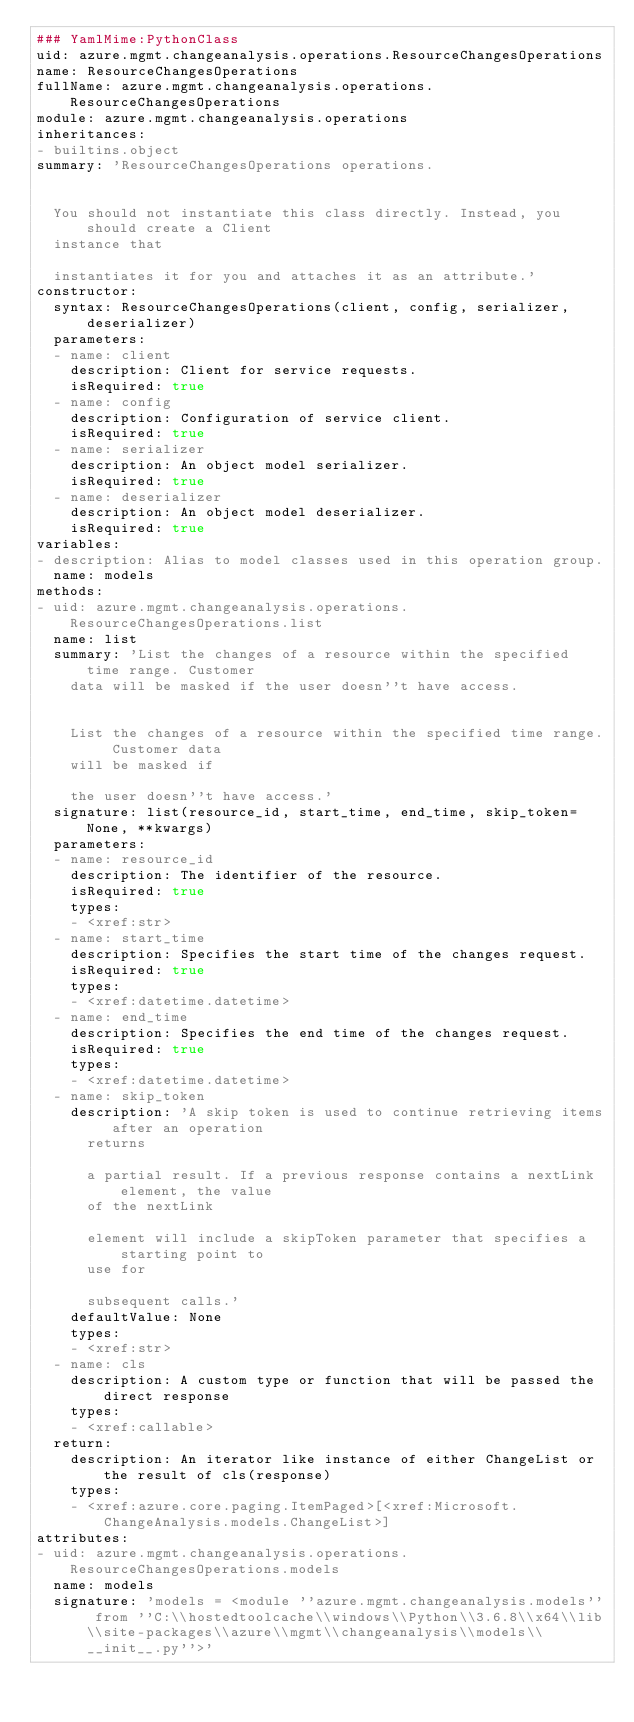<code> <loc_0><loc_0><loc_500><loc_500><_YAML_>### YamlMime:PythonClass
uid: azure.mgmt.changeanalysis.operations.ResourceChangesOperations
name: ResourceChangesOperations
fullName: azure.mgmt.changeanalysis.operations.ResourceChangesOperations
module: azure.mgmt.changeanalysis.operations
inheritances:
- builtins.object
summary: 'ResourceChangesOperations operations.


  You should not instantiate this class directly. Instead, you should create a Client
  instance that

  instantiates it for you and attaches it as an attribute.'
constructor:
  syntax: ResourceChangesOperations(client, config, serializer, deserializer)
  parameters:
  - name: client
    description: Client for service requests.
    isRequired: true
  - name: config
    description: Configuration of service client.
    isRequired: true
  - name: serializer
    description: An object model serializer.
    isRequired: true
  - name: deserializer
    description: An object model deserializer.
    isRequired: true
variables:
- description: Alias to model classes used in this operation group.
  name: models
methods:
- uid: azure.mgmt.changeanalysis.operations.ResourceChangesOperations.list
  name: list
  summary: 'List the changes of a resource within the specified time range. Customer
    data will be masked if the user doesn''t have access.


    List the changes of a resource within the specified time range. Customer data
    will be masked if

    the user doesn''t have access.'
  signature: list(resource_id, start_time, end_time, skip_token=None, **kwargs)
  parameters:
  - name: resource_id
    description: The identifier of the resource.
    isRequired: true
    types:
    - <xref:str>
  - name: start_time
    description: Specifies the start time of the changes request.
    isRequired: true
    types:
    - <xref:datetime.datetime>
  - name: end_time
    description: Specifies the end time of the changes request.
    isRequired: true
    types:
    - <xref:datetime.datetime>
  - name: skip_token
    description: 'A skip token is used to continue retrieving items after an operation
      returns

      a partial result. If a previous response contains a nextLink element, the value
      of the nextLink

      element will include a skipToken parameter that specifies a starting point to
      use for

      subsequent calls.'
    defaultValue: None
    types:
    - <xref:str>
  - name: cls
    description: A custom type or function that will be passed the direct response
    types:
    - <xref:callable>
  return:
    description: An iterator like instance of either ChangeList or the result of cls(response)
    types:
    - <xref:azure.core.paging.ItemPaged>[<xref:Microsoft.ChangeAnalysis.models.ChangeList>]
attributes:
- uid: azure.mgmt.changeanalysis.operations.ResourceChangesOperations.models
  name: models
  signature: 'models = <module ''azure.mgmt.changeanalysis.models'' from ''C:\\hostedtoolcache\\windows\\Python\\3.6.8\\x64\\lib\\site-packages\\azure\\mgmt\\changeanalysis\\models\\__init__.py''>'
</code> 